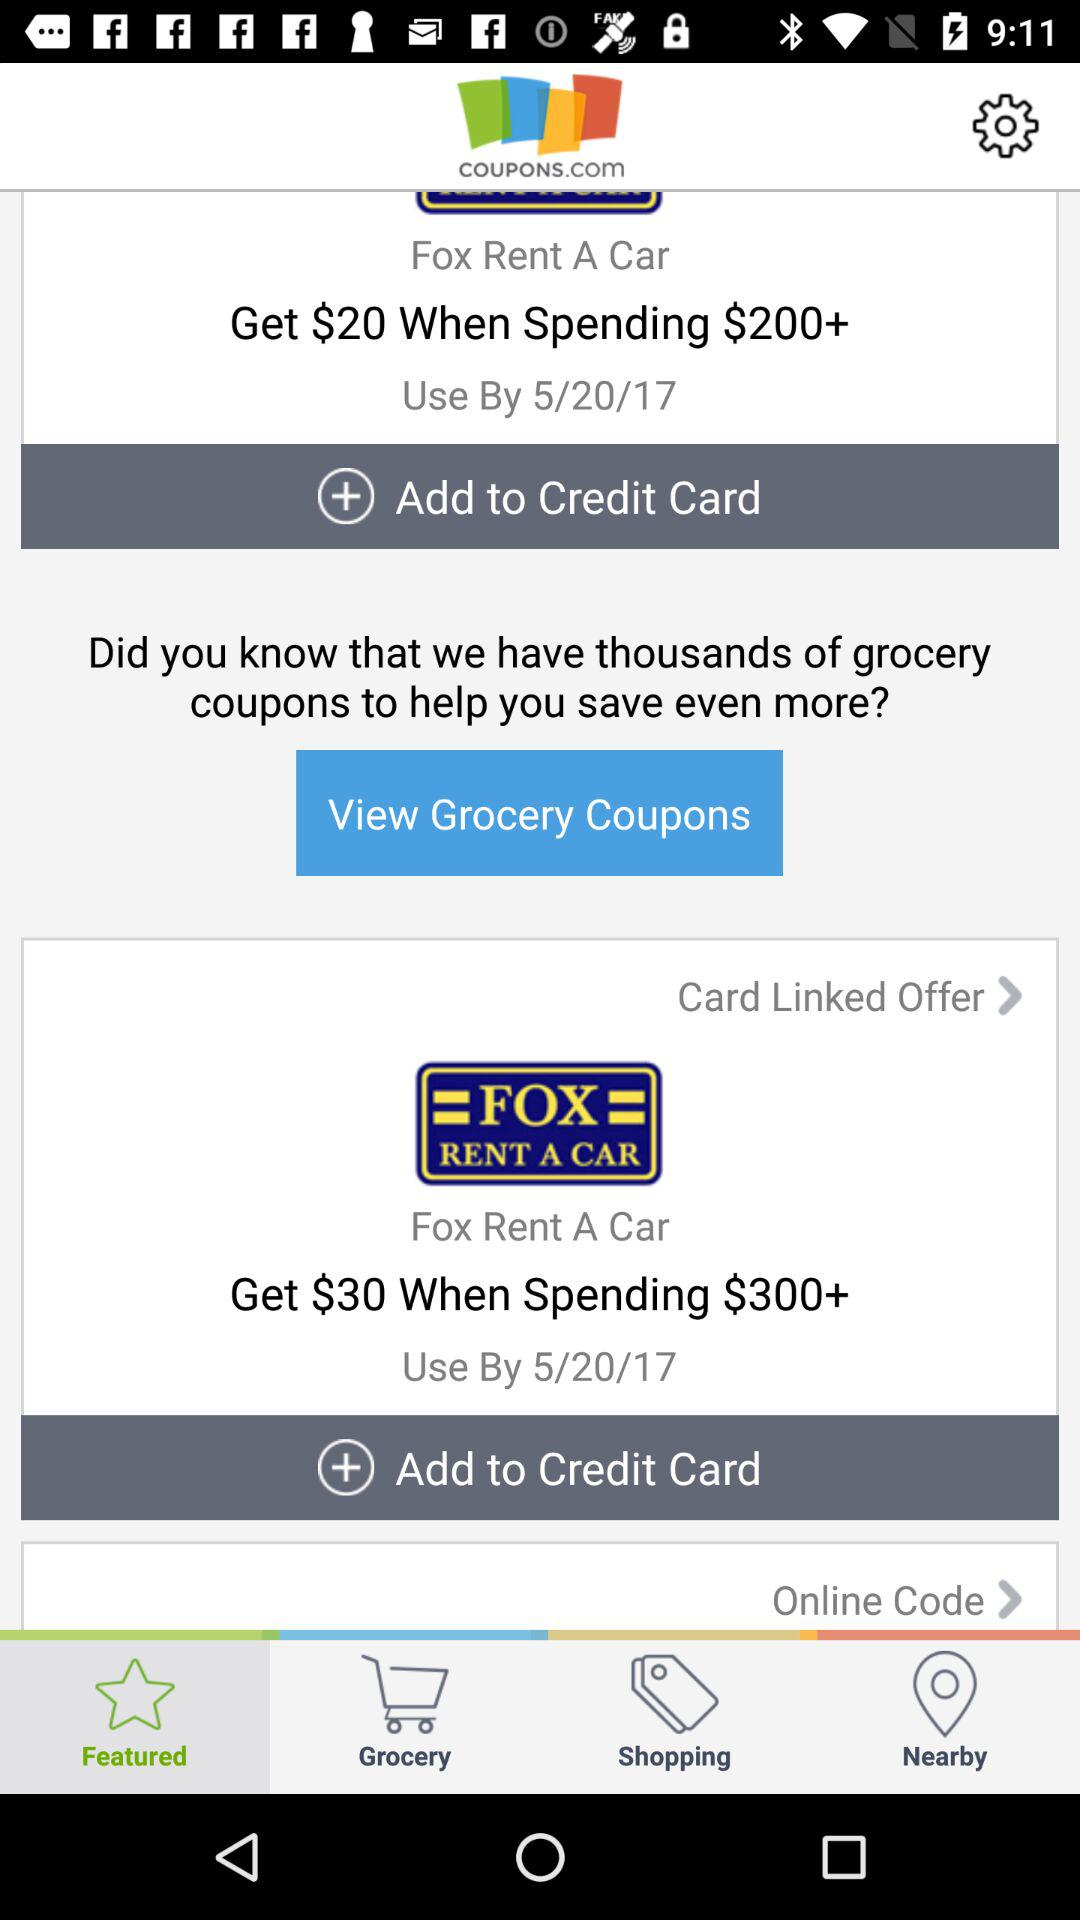How much more is the value of the second coupon than the first?
Answer the question using a single word or phrase. $10 